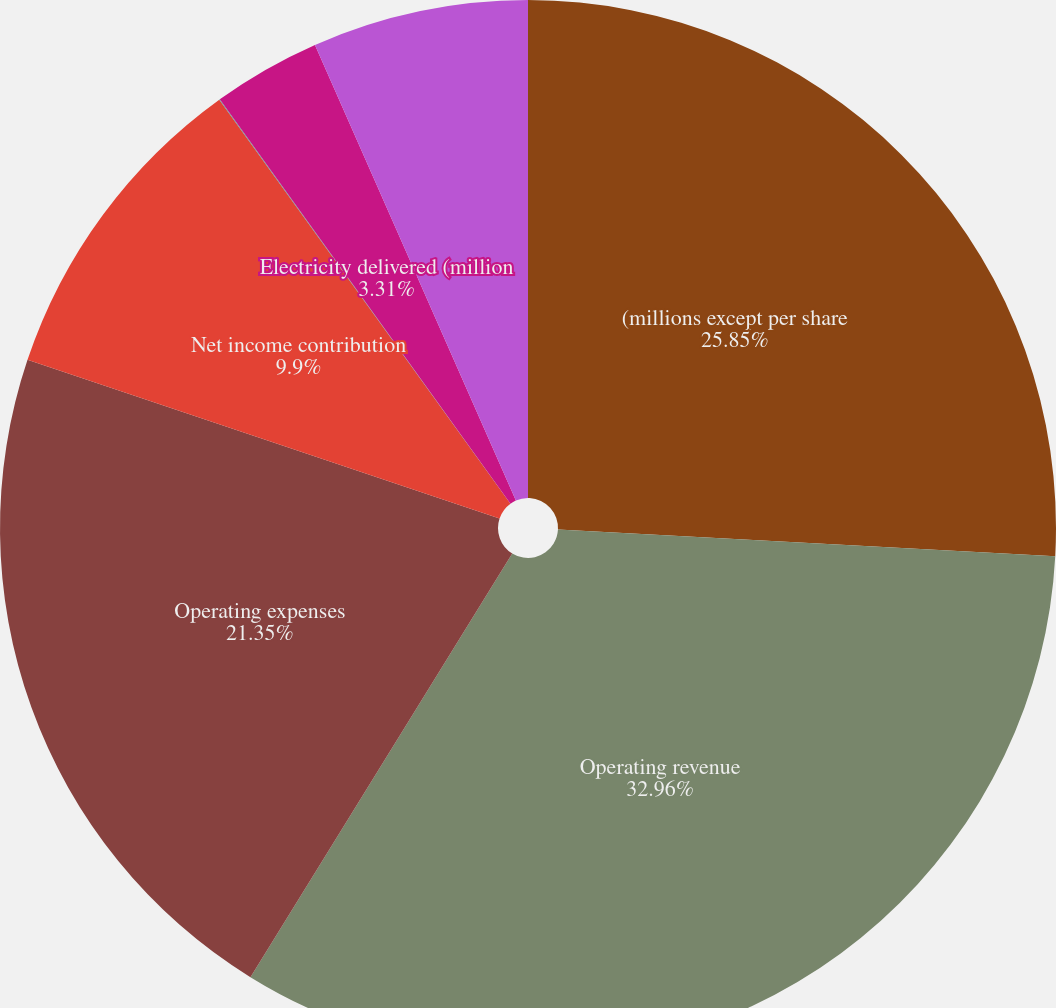Convert chart to OTSL. <chart><loc_0><loc_0><loc_500><loc_500><pie_chart><fcel>(millions except per share<fcel>Operating revenue<fcel>Operating expenses<fcel>Net income contribution<fcel>Earnings per share<fcel>Electricity delivered (million<fcel>Gas throughput (mmcf)<nl><fcel>25.85%<fcel>32.96%<fcel>21.35%<fcel>9.9%<fcel>0.02%<fcel>3.31%<fcel>6.61%<nl></chart> 